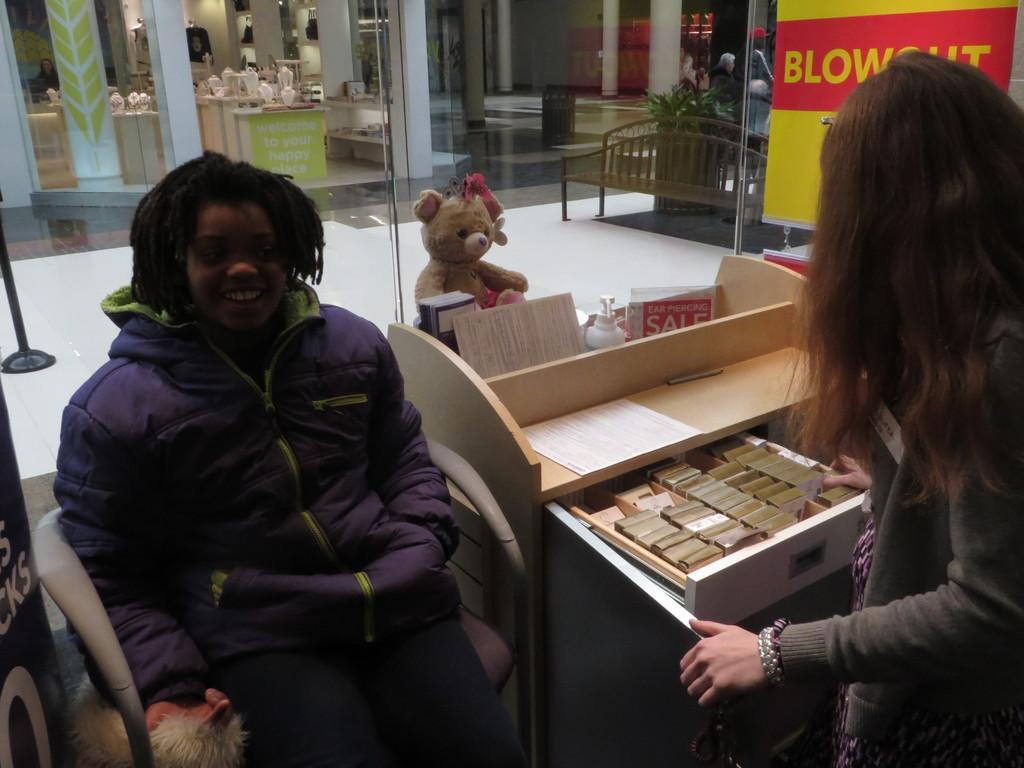What is the position of the woman in the image? There is a woman seated in the image. What is the facial expression of the seated woman? The seated woman is smiling. Are there any other women in the image? Yes, there is a woman standing in the image. What type of plants can be seen growing out of the woman's head in the image? There are no plants visible in the image, and the woman's head does not appear to have any plants growing out of it. 